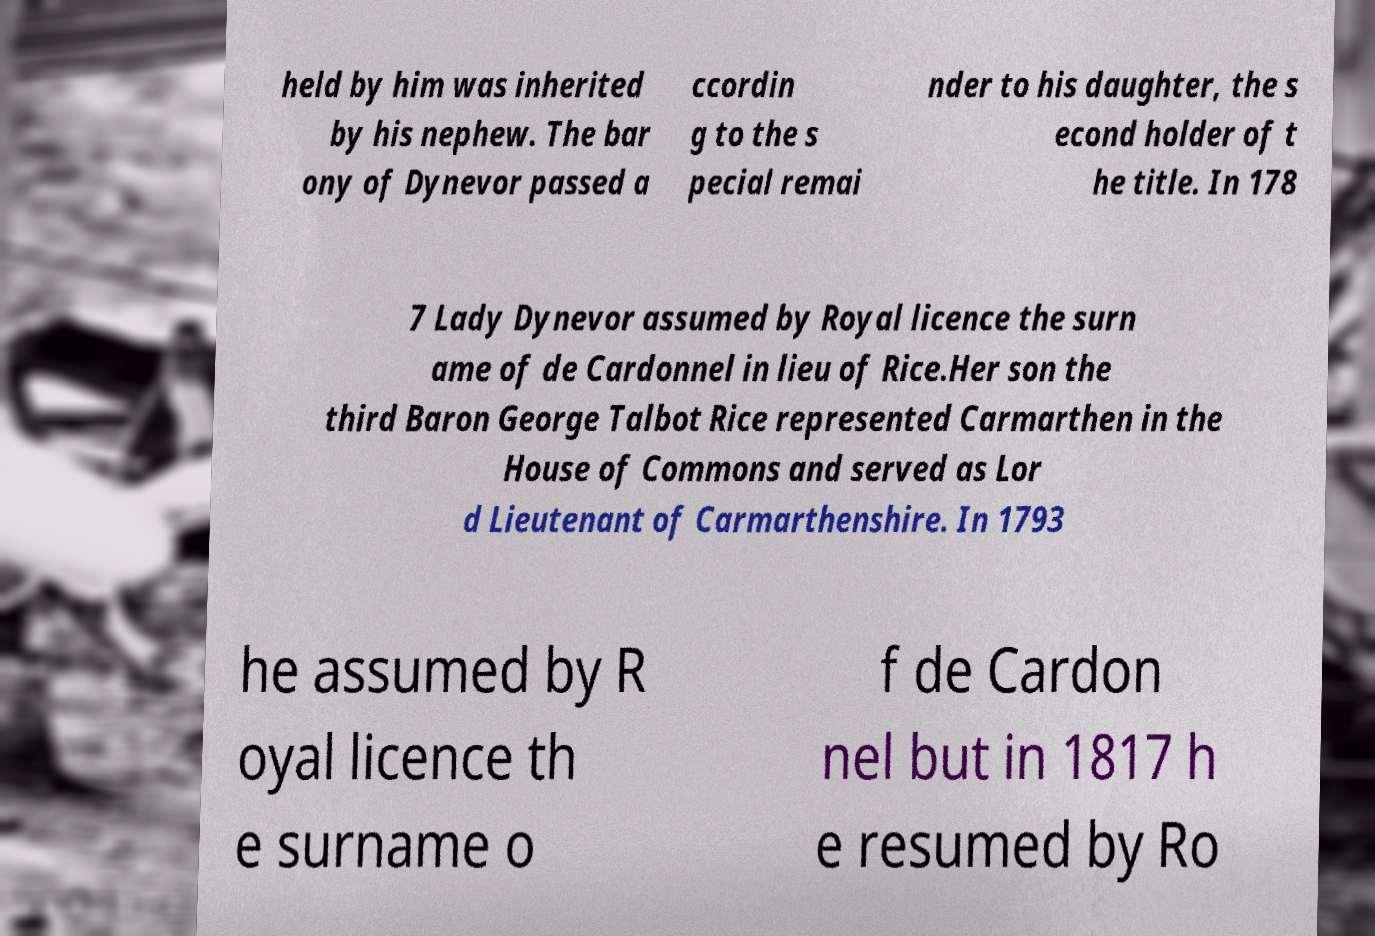For documentation purposes, I need the text within this image transcribed. Could you provide that? held by him was inherited by his nephew. The bar ony of Dynevor passed a ccordin g to the s pecial remai nder to his daughter, the s econd holder of t he title. In 178 7 Lady Dynevor assumed by Royal licence the surn ame of de Cardonnel in lieu of Rice.Her son the third Baron George Talbot Rice represented Carmarthen in the House of Commons and served as Lor d Lieutenant of Carmarthenshire. In 1793 he assumed by R oyal licence th e surname o f de Cardon nel but in 1817 h e resumed by Ro 